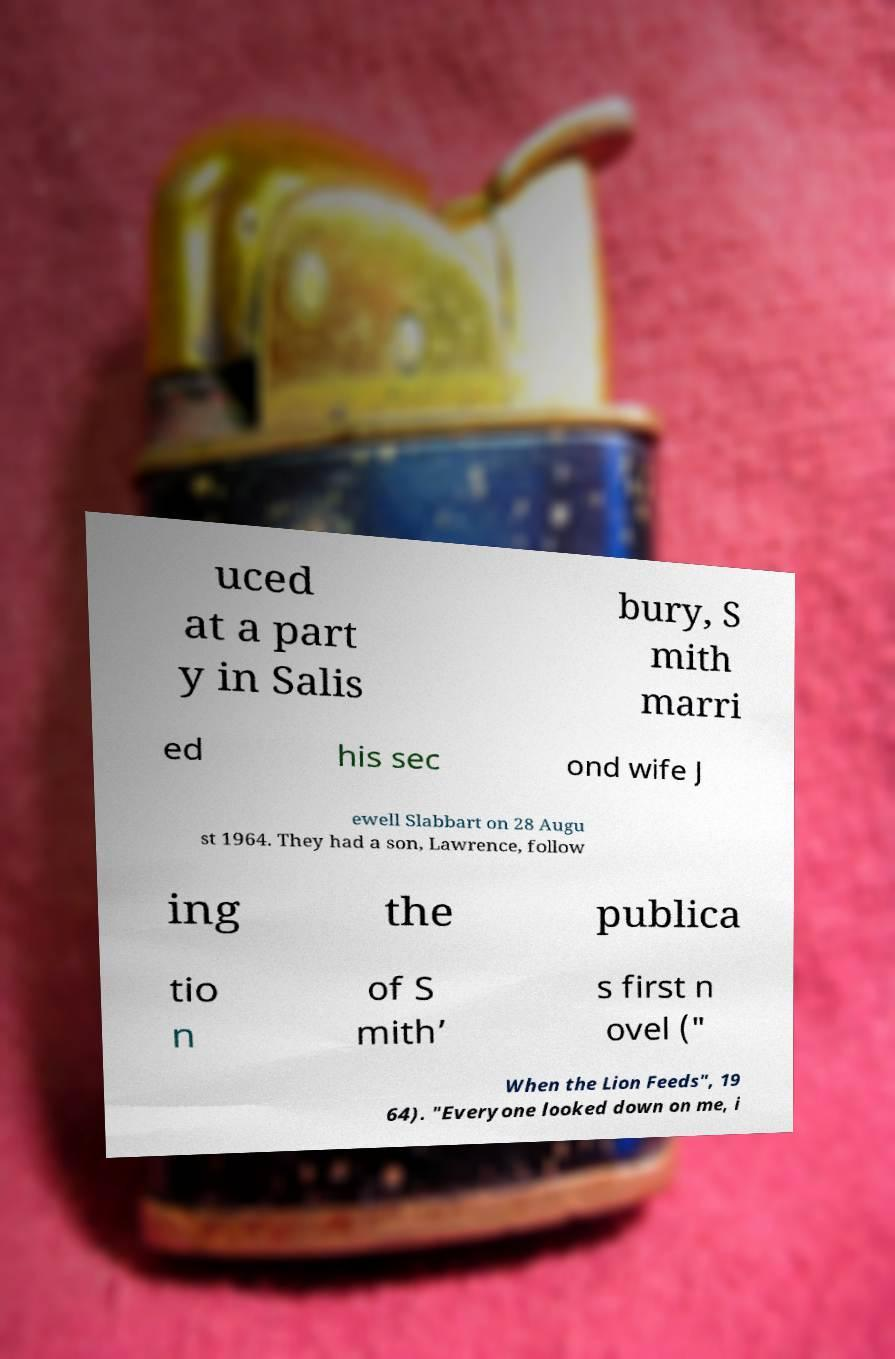For documentation purposes, I need the text within this image transcribed. Could you provide that? uced at a part y in Salis bury, S mith marri ed his sec ond wife J ewell Slabbart on 28 Augu st 1964. They had a son, Lawrence, follow ing the publica tio n of S mith’ s first n ovel (" When the Lion Feeds", 19 64). "Everyone looked down on me, i 